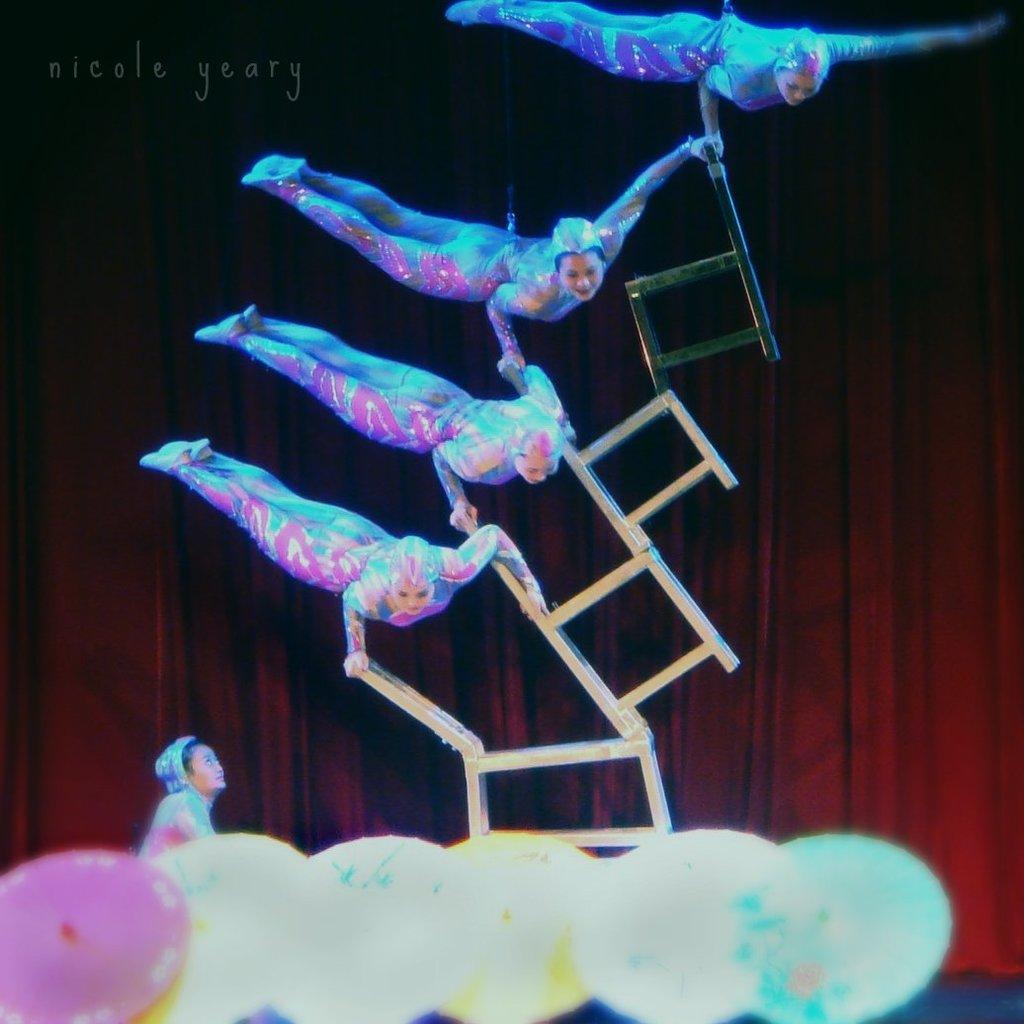In one or two sentences, can you explain what this image depicts? In this image I can see few people and I can see all of them are wearing costumes. In the front of this image I can see few colourful things and in the background I can see red colour curtain. I can also see few chairs in the centre and on the top left side of this image I can see a watermark. 